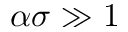Convert formula to latex. <formula><loc_0><loc_0><loc_500><loc_500>\alpha \sigma \gg 1</formula> 